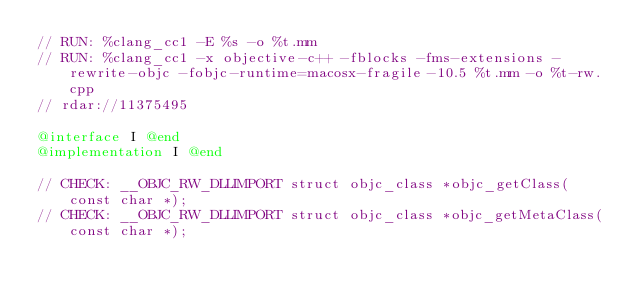<code> <loc_0><loc_0><loc_500><loc_500><_ObjectiveC_>// RUN: %clang_cc1 -E %s -o %t.mm
// RUN: %clang_cc1 -x objective-c++ -fblocks -fms-extensions -rewrite-objc -fobjc-runtime=macosx-fragile-10.5 %t.mm -o %t-rw.cpp
// rdar://11375495

@interface I @end
@implementation I @end

// CHECK: __OBJC_RW_DLLIMPORT struct objc_class *objc_getClass(const char *);
// CHECK: __OBJC_RW_DLLIMPORT struct objc_class *objc_getMetaClass(const char *);

</code> 